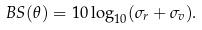Convert formula to latex. <formula><loc_0><loc_0><loc_500><loc_500>B S ( \theta ) = 1 0 \log _ { 1 0 } ( \sigma _ { r } + \sigma _ { v } ) .</formula> 